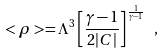Convert formula to latex. <formula><loc_0><loc_0><loc_500><loc_500>< \rho > = \Lambda ^ { 3 } \left [ \frac { \gamma - 1 } { 2 | C | } \right ] ^ { \frac { 1 } { \gamma - 1 } } \ ,</formula> 